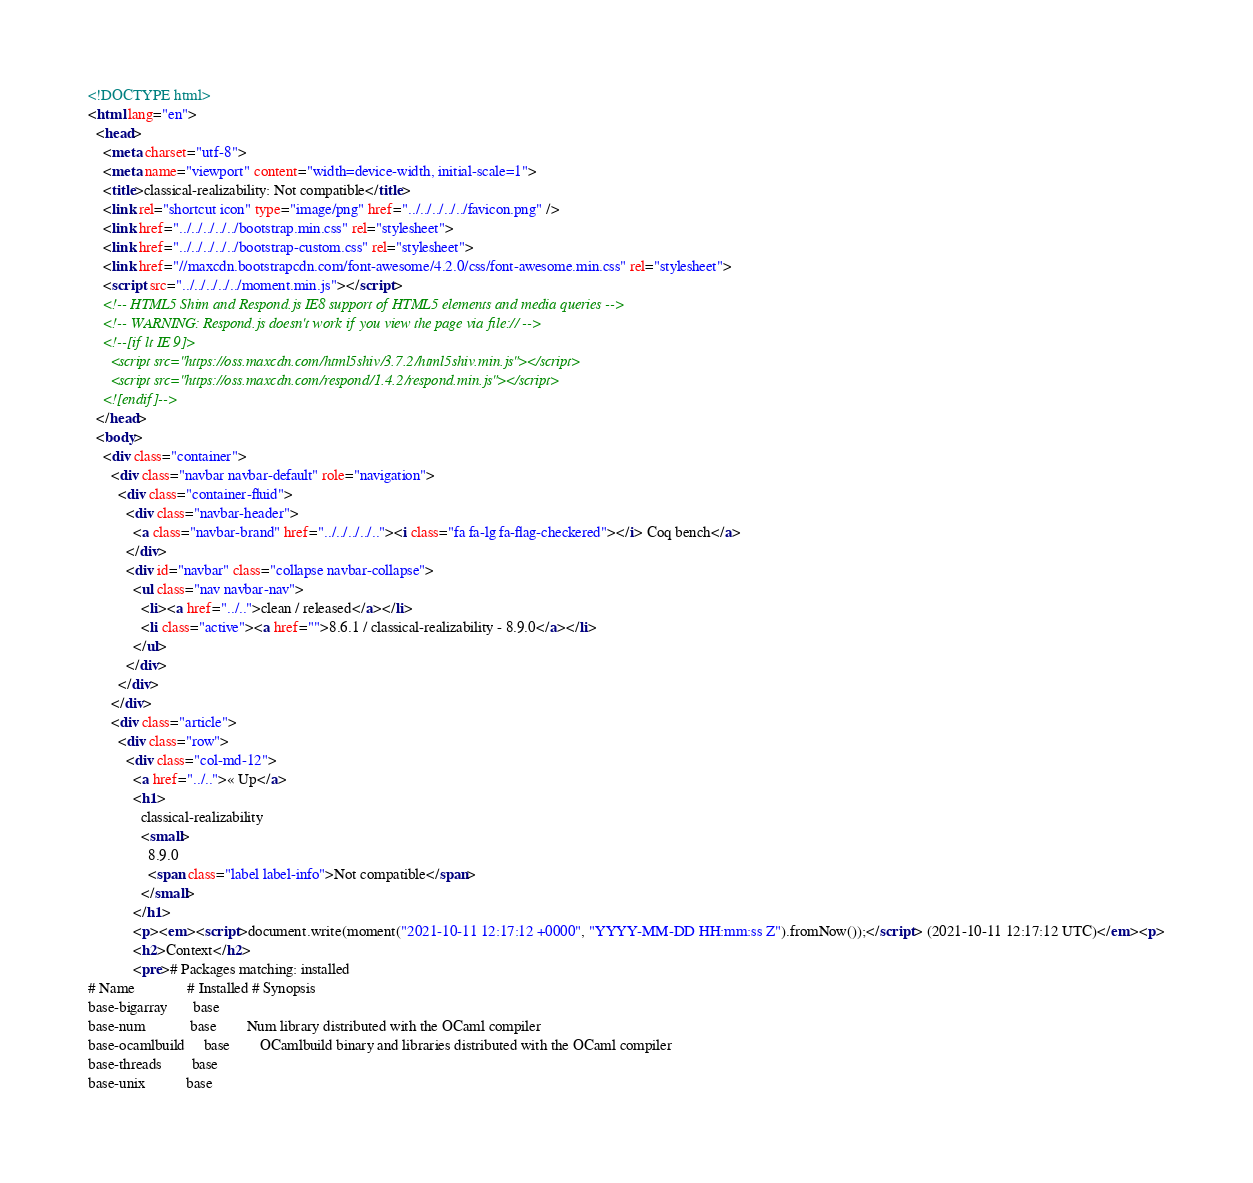<code> <loc_0><loc_0><loc_500><loc_500><_HTML_><!DOCTYPE html>
<html lang="en">
  <head>
    <meta charset="utf-8">
    <meta name="viewport" content="width=device-width, initial-scale=1">
    <title>classical-realizability: Not compatible</title>
    <link rel="shortcut icon" type="image/png" href="../../../../../favicon.png" />
    <link href="../../../../../bootstrap.min.css" rel="stylesheet">
    <link href="../../../../../bootstrap-custom.css" rel="stylesheet">
    <link href="//maxcdn.bootstrapcdn.com/font-awesome/4.2.0/css/font-awesome.min.css" rel="stylesheet">
    <script src="../../../../../moment.min.js"></script>
    <!-- HTML5 Shim and Respond.js IE8 support of HTML5 elements and media queries -->
    <!-- WARNING: Respond.js doesn't work if you view the page via file:// -->
    <!--[if lt IE 9]>
      <script src="https://oss.maxcdn.com/html5shiv/3.7.2/html5shiv.min.js"></script>
      <script src="https://oss.maxcdn.com/respond/1.4.2/respond.min.js"></script>
    <![endif]-->
  </head>
  <body>
    <div class="container">
      <div class="navbar navbar-default" role="navigation">
        <div class="container-fluid">
          <div class="navbar-header">
            <a class="navbar-brand" href="../../../../.."><i class="fa fa-lg fa-flag-checkered"></i> Coq bench</a>
          </div>
          <div id="navbar" class="collapse navbar-collapse">
            <ul class="nav navbar-nav">
              <li><a href="../..">clean / released</a></li>
              <li class="active"><a href="">8.6.1 / classical-realizability - 8.9.0</a></li>
            </ul>
          </div>
        </div>
      </div>
      <div class="article">
        <div class="row">
          <div class="col-md-12">
            <a href="../..">« Up</a>
            <h1>
              classical-realizability
              <small>
                8.9.0
                <span class="label label-info">Not compatible</span>
              </small>
            </h1>
            <p><em><script>document.write(moment("2021-10-11 12:17:12 +0000", "YYYY-MM-DD HH:mm:ss Z").fromNow());</script> (2021-10-11 12:17:12 UTC)</em><p>
            <h2>Context</h2>
            <pre># Packages matching: installed
# Name              # Installed # Synopsis
base-bigarray       base
base-num            base        Num library distributed with the OCaml compiler
base-ocamlbuild     base        OCamlbuild binary and libraries distributed with the OCaml compiler
base-threads        base
base-unix           base</code> 